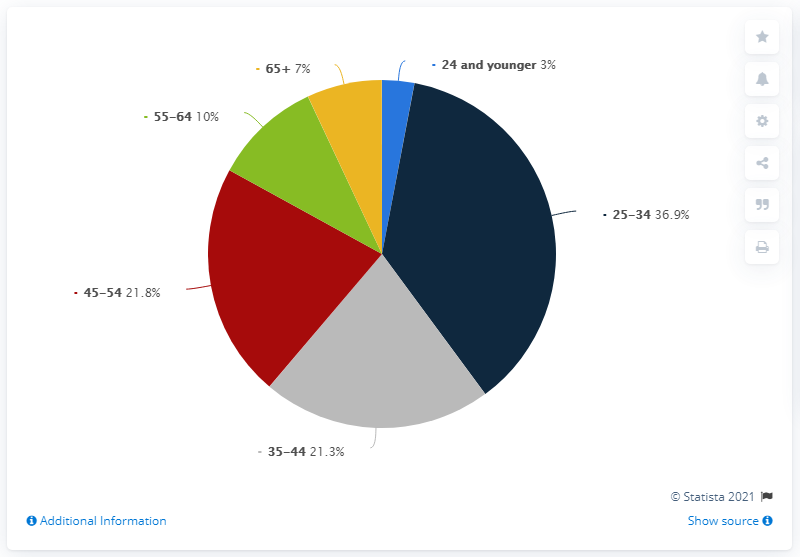List a handful of essential elements in this visual. There are six categories of age. The average of red and green is 15.9. 